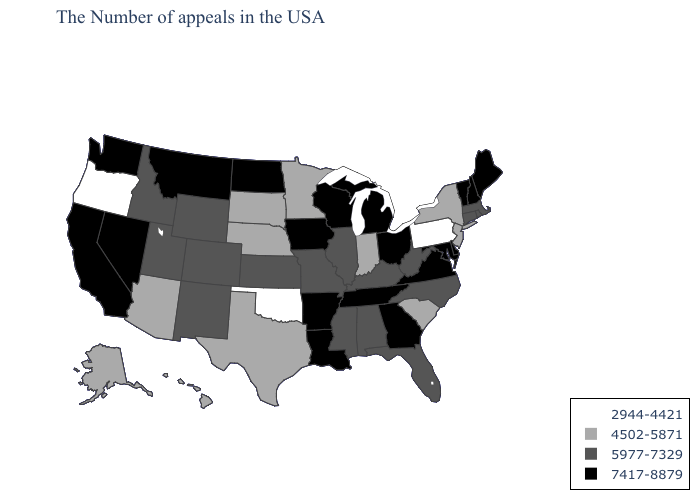Among the states that border Mississippi , which have the lowest value?
Keep it brief. Alabama. What is the value of Montana?
Be succinct. 7417-8879. Name the states that have a value in the range 5977-7329?
Be succinct. Massachusetts, Rhode Island, Connecticut, North Carolina, West Virginia, Florida, Kentucky, Alabama, Illinois, Mississippi, Missouri, Kansas, Wyoming, Colorado, New Mexico, Utah, Idaho. Is the legend a continuous bar?
Be succinct. No. Which states hav the highest value in the West?
Write a very short answer. Montana, Nevada, California, Washington. Name the states that have a value in the range 2944-4421?
Short answer required. Pennsylvania, Oklahoma, Oregon. Name the states that have a value in the range 4502-5871?
Give a very brief answer. New York, New Jersey, South Carolina, Indiana, Minnesota, Nebraska, Texas, South Dakota, Arizona, Alaska, Hawaii. What is the value of Connecticut?
Short answer required. 5977-7329. What is the value of Kentucky?
Answer briefly. 5977-7329. What is the highest value in states that border Mississippi?
Short answer required. 7417-8879. What is the lowest value in the MidWest?
Write a very short answer. 4502-5871. What is the value of Pennsylvania?
Answer briefly. 2944-4421. Does Delaware have the highest value in the USA?
Give a very brief answer. Yes. Name the states that have a value in the range 2944-4421?
Short answer required. Pennsylvania, Oklahoma, Oregon. 